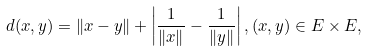Convert formula to latex. <formula><loc_0><loc_0><loc_500><loc_500>d ( x , y ) = \| x - y \| + \left | \frac { 1 } { \| x \| } - \frac { 1 } { \| y \| } \right | , ( x , y ) \in E \times E ,</formula> 